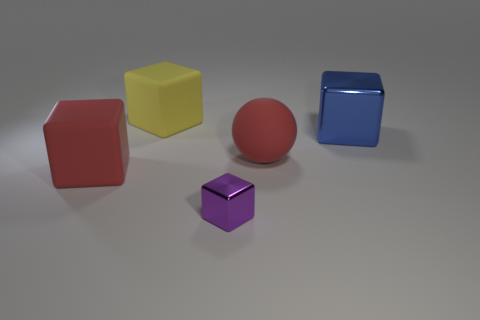Are there any other things that have the same size as the purple cube?
Keep it short and to the point. No. Are there the same number of big things behind the large yellow rubber block and red matte objects that are on the right side of the sphere?
Offer a terse response. Yes. What material is the large cube to the right of the tiny metallic block?
Your answer should be very brief. Metal. What number of objects are either red rubber objects right of the purple metallic block or small purple things?
Provide a succinct answer. 2. What number of other objects are the same shape as the large blue metal thing?
Offer a terse response. 3. There is a big red object left of the tiny purple object; is its shape the same as the big shiny thing?
Give a very brief answer. Yes. Are there any red matte objects left of the tiny shiny thing?
Your response must be concise. Yes. How many big things are metallic things or red rubber cubes?
Give a very brief answer. 2. Are the big yellow block and the big red ball made of the same material?
Your response must be concise. Yes. Are there any big objects of the same color as the ball?
Your answer should be very brief. Yes. 